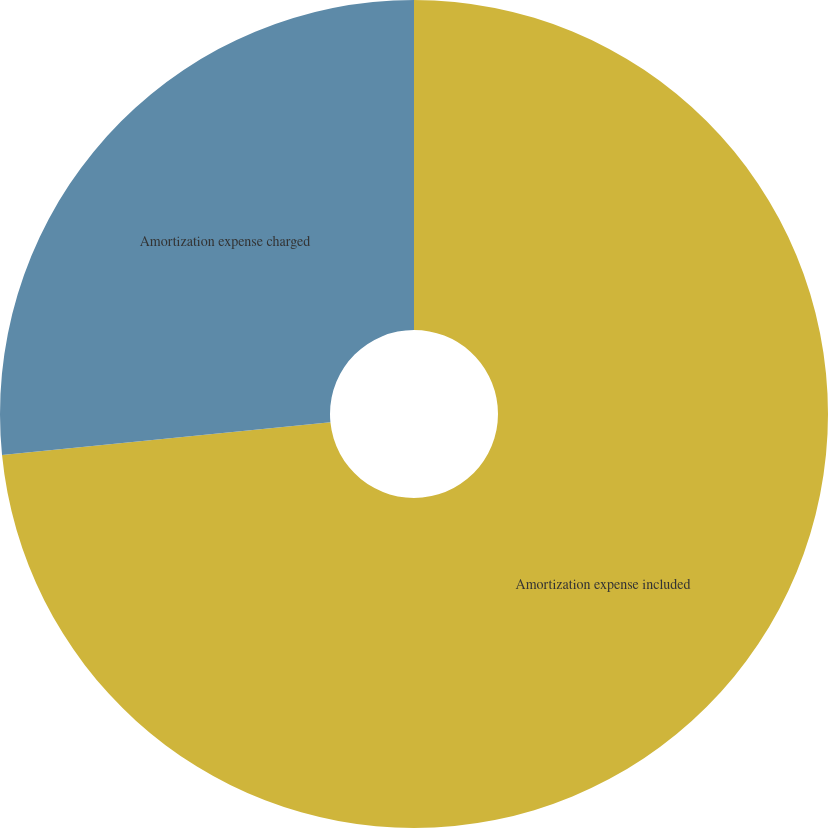Convert chart. <chart><loc_0><loc_0><loc_500><loc_500><pie_chart><fcel>Amortization expense included<fcel>Amortization expense charged<nl><fcel>73.42%<fcel>26.58%<nl></chart> 